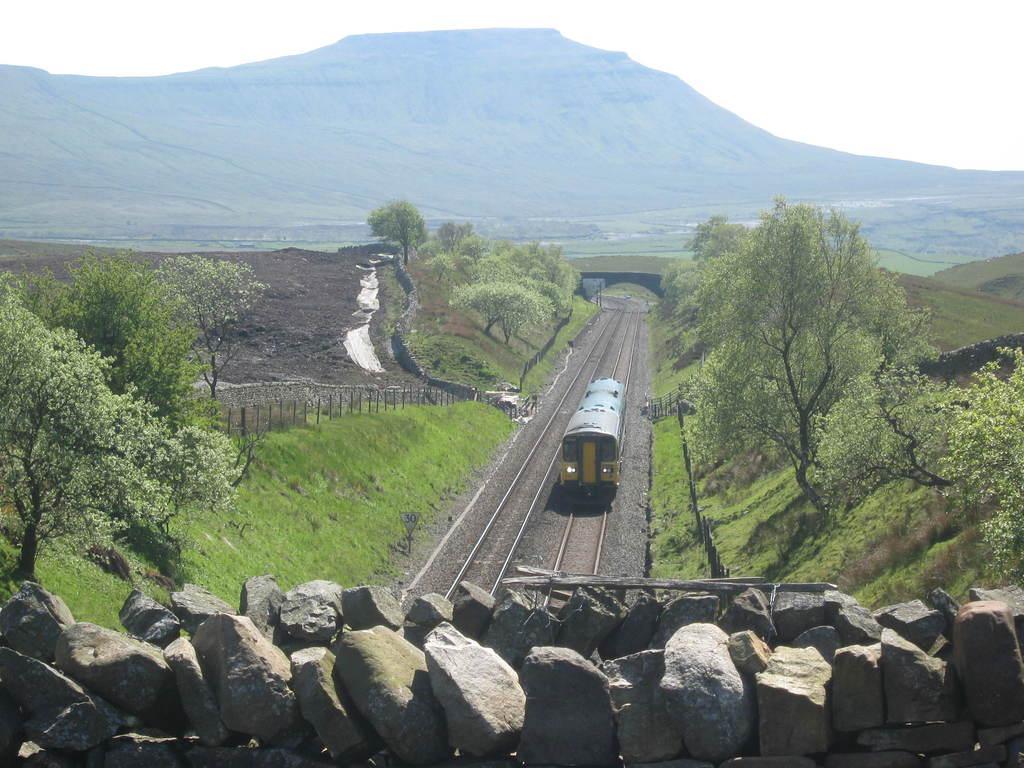How would you summarize this image in a sentence or two? In the center of the image we can see a train on the track and there is a bridge. At the bottom there are stones. In the background there are trees, fence, hills and sky. 